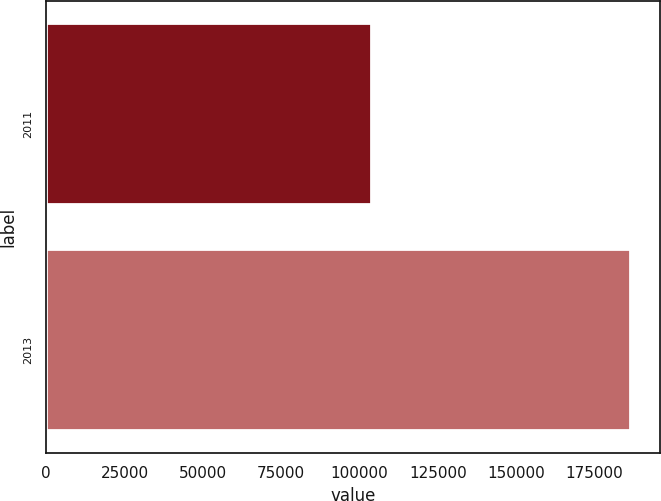Convert chart. <chart><loc_0><loc_0><loc_500><loc_500><bar_chart><fcel>2011<fcel>2013<nl><fcel>103532<fcel>186460<nl></chart> 